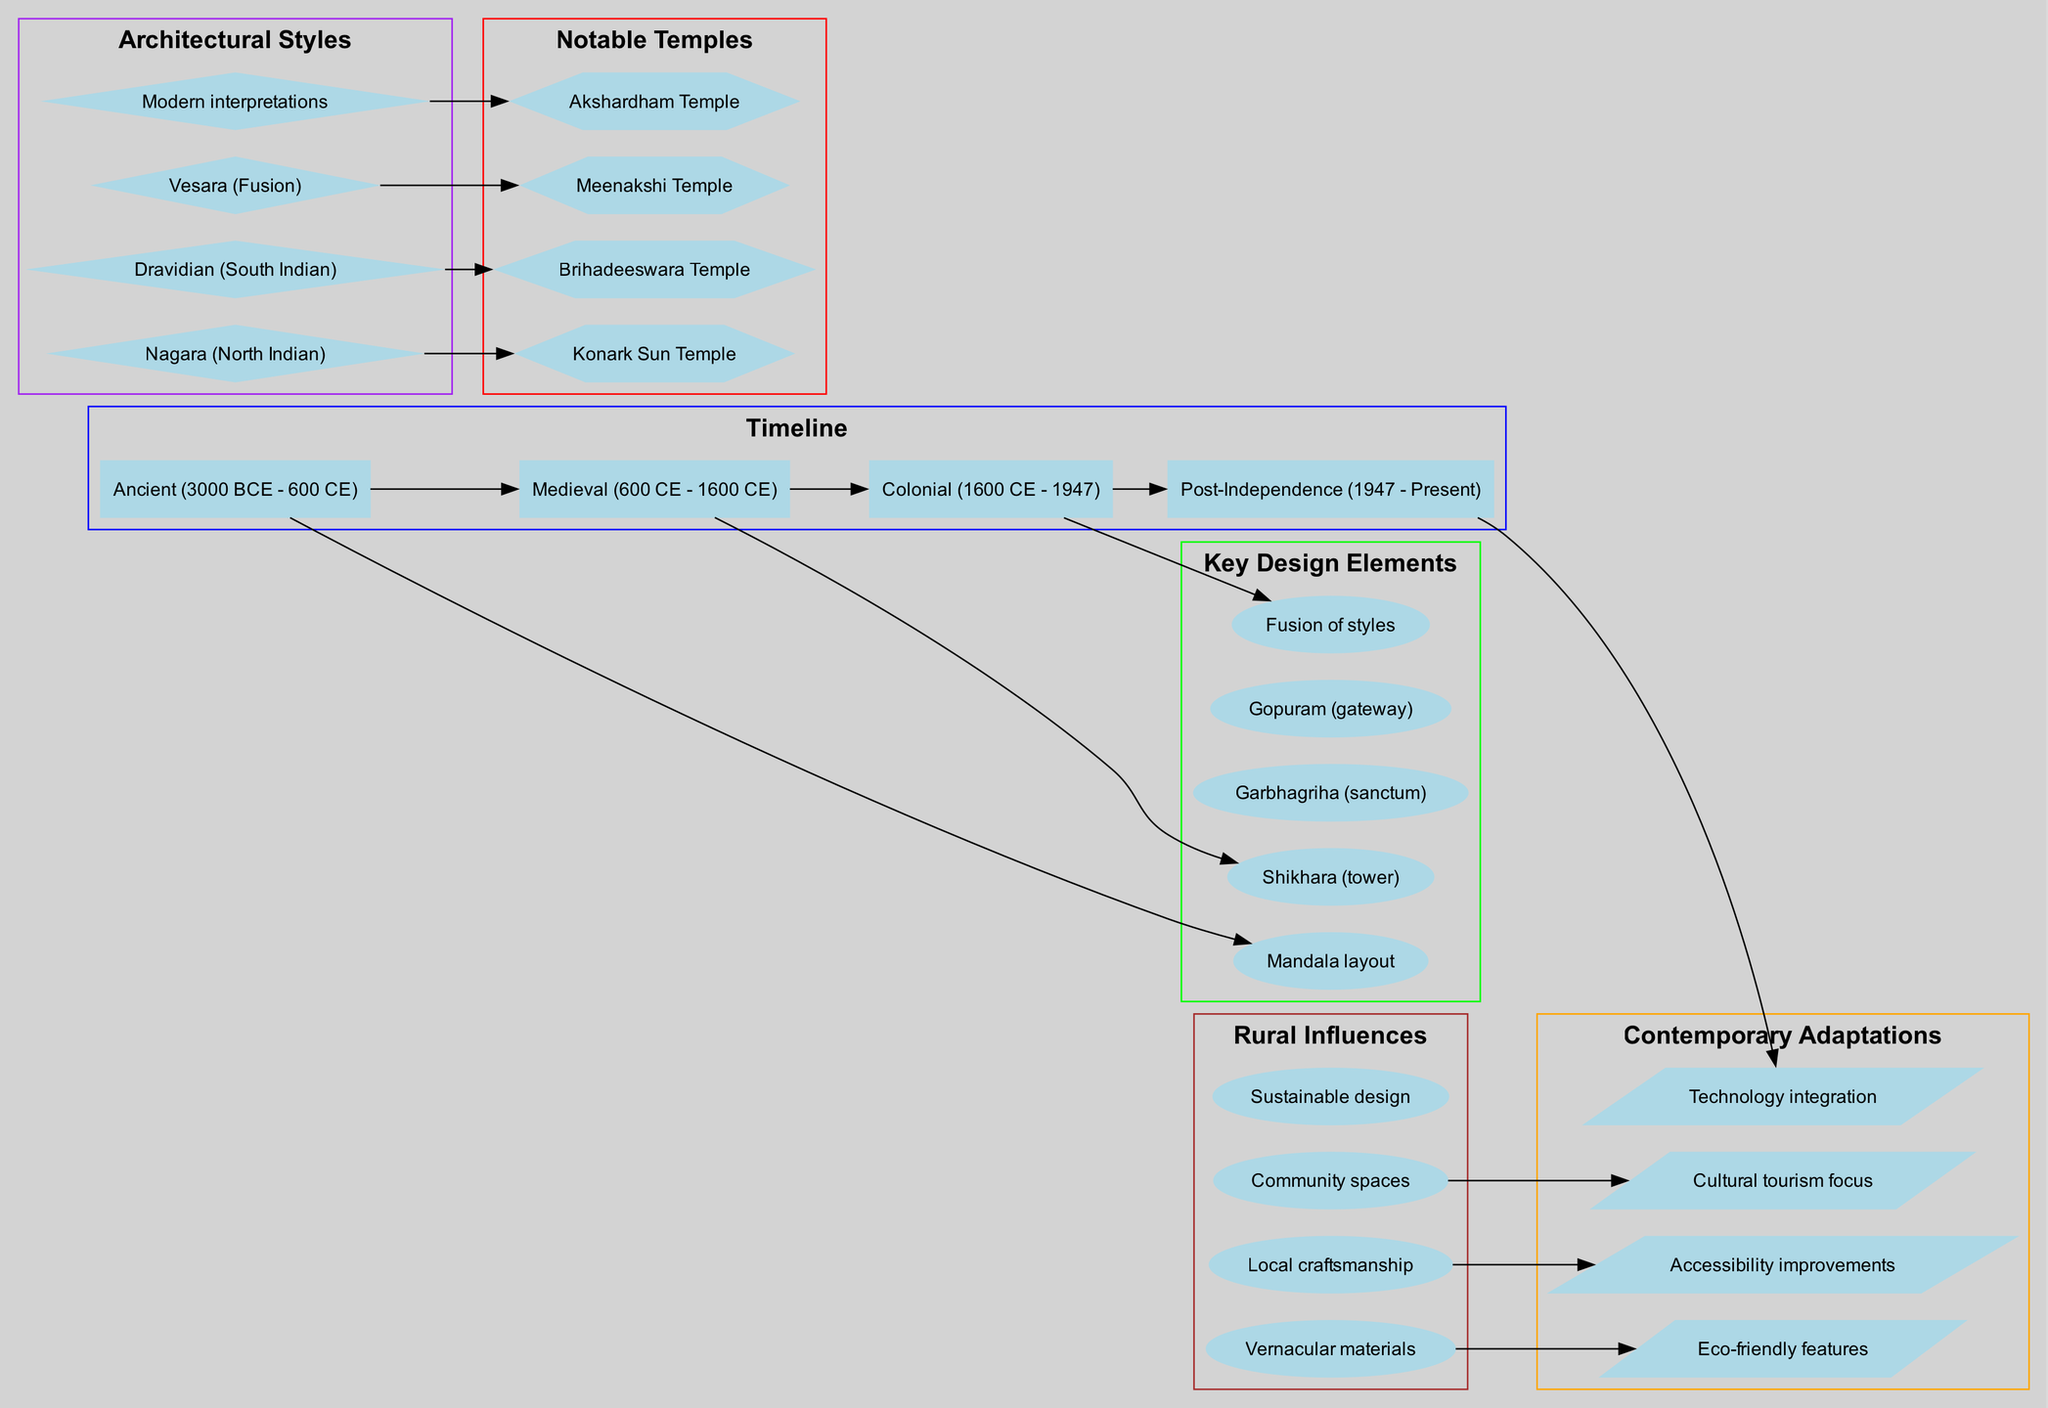What is the timeline period for Medieval architecture? The diagram lists different eras in the timeline, and the Medieval period is explicitly labeled from 600 CE to 1600 CE.
Answer: 600 CE - 1600 CE Which notable temple is associated with the Dravidian architectural style? Looking at the architectural styles section and notable temples, the Meenakshi Temple is directly linked to the Dravidian style.
Answer: Meenakshi Temple How many key design elements are listed in the diagram? By counting the items in the key design elements section, there are a total of five elements.
Answer: 5 What contemporary adaptation focuses on cultural engagement? Reviewing the contemporary adaptations, the "Cultural tourism focus" is the item that specifically relates to engaging the culture.
Answer: Cultural tourism focus How many rural influences are mentioned in the diagram? The rural influences section contains four items that indicate different aspects of rural design influences in architecture.
Answer: 4 Which era is connected to the fusion of architectural styles? Tracing the timeline, the Colonial era from 1600 CE to 1947 is linked to the design element "Fusion of styles."
Answer: Colonial (1600 CE - 1947) What is the shape of the nodes used for key design elements? Inspecting the diagram nodes for key design elements, they are represented in the shape of ellipses.
Answer: Ellipse Which notable temple corresponds to the Nagara style? Looking at the diagram, the Konark Sun Temple is associated with the Nagara architectural style.
Answer: Konark Sun Temple Name one contemporary adaptation that emphasizes eco-friendly features. In the contemporary adaptations section, "Eco-friendly features" directly mentions sustainable practices in modern temple architecture.
Answer: Eco-friendly features 